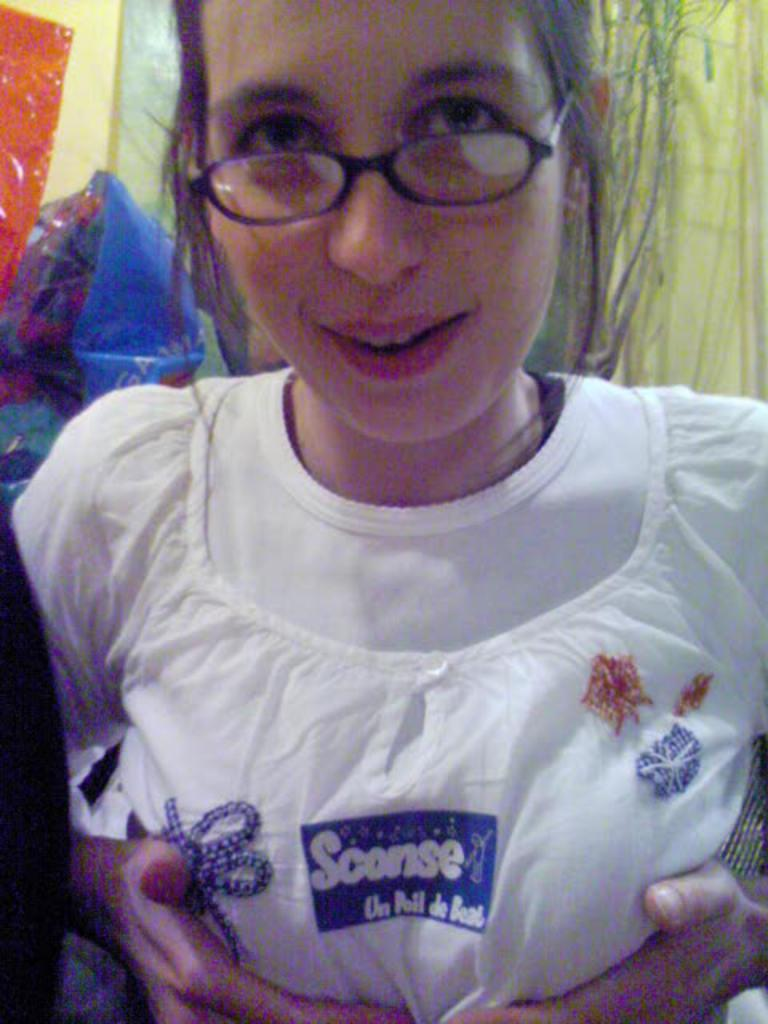Who is present in the image? There is a woman in the image. What is the woman wearing? The woman is wearing spectacles. What can be seen in the background of the image? There are objects in the background of the image. How does the woman increase her memory in the image? There is no indication in the image that the woman is trying to increase her memory, nor is there any information about her memory capacity. 